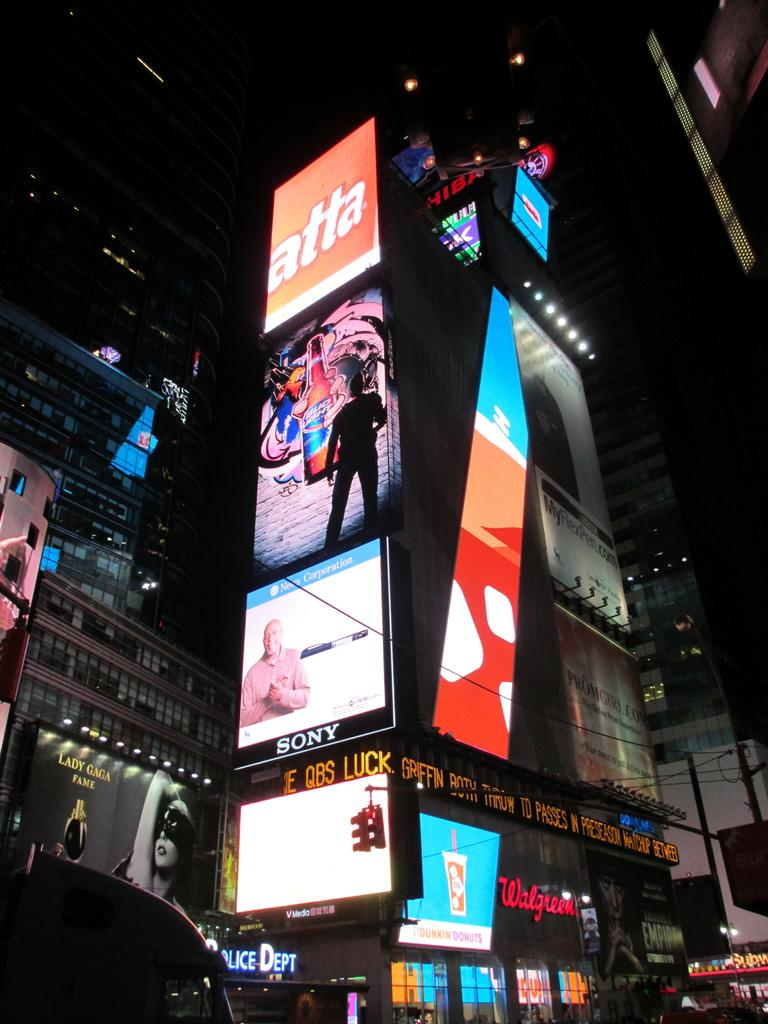What type of structures are visible in the image? There are buildings in the image. What else can be seen on the buildings? There are hoardings on the buildings. Are there any specific features of the buildings mentioned? Yes, there are glass windows in the image. What else is present in the image besides the buildings? There are lights and a car in the foreground of the image. How would you describe the lighting conditions in the image? The top part of the image is dark. Where is the cat sitting in the image? There is no cat present in the image. What type of authority is depicted in the image? The image does not depict any authority figures or institutions. 